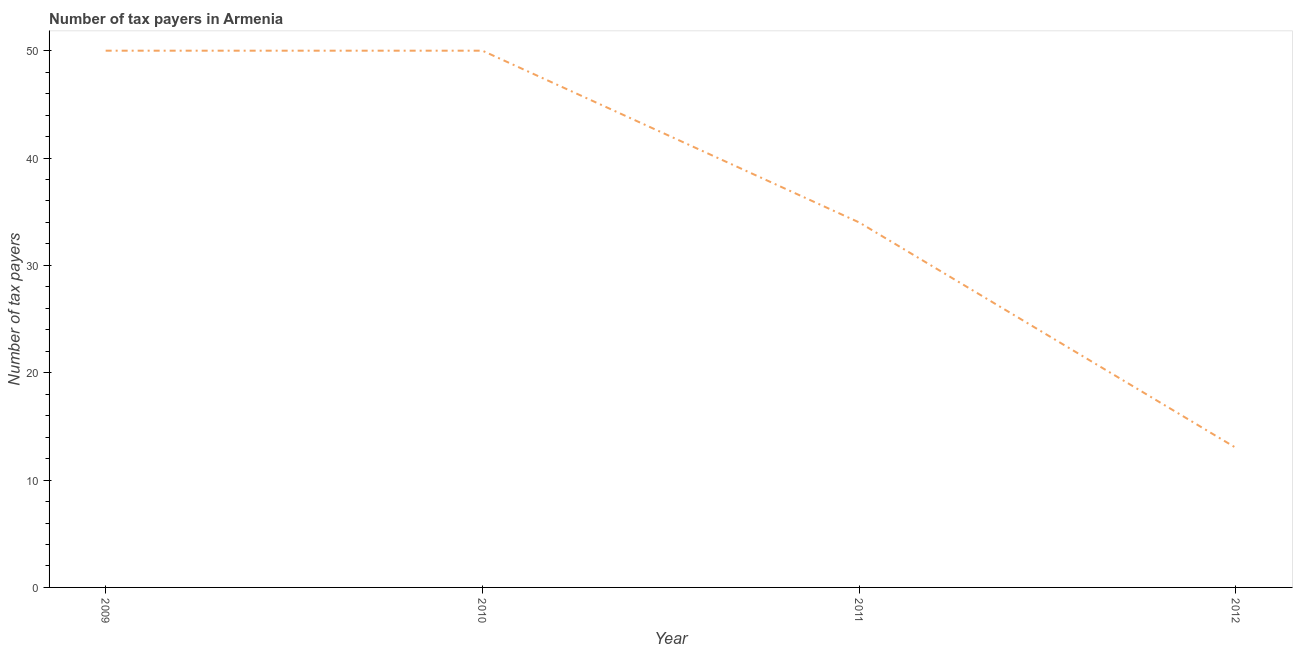What is the number of tax payers in 2009?
Provide a succinct answer. 50. Across all years, what is the maximum number of tax payers?
Offer a terse response. 50. Across all years, what is the minimum number of tax payers?
Your answer should be compact. 13. What is the sum of the number of tax payers?
Your response must be concise. 147. What is the difference between the number of tax payers in 2010 and 2011?
Your response must be concise. 16. What is the average number of tax payers per year?
Ensure brevity in your answer.  36.75. Do a majority of the years between 2009 and 2010 (inclusive) have number of tax payers greater than 22 ?
Your answer should be compact. Yes. What is the ratio of the number of tax payers in 2011 to that in 2012?
Your response must be concise. 2.62. What is the difference between the highest and the lowest number of tax payers?
Keep it short and to the point. 37. In how many years, is the number of tax payers greater than the average number of tax payers taken over all years?
Make the answer very short. 2. Does the number of tax payers monotonically increase over the years?
Your answer should be compact. No. How many lines are there?
Your answer should be compact. 1. How many years are there in the graph?
Give a very brief answer. 4. What is the difference between two consecutive major ticks on the Y-axis?
Your answer should be very brief. 10. What is the title of the graph?
Ensure brevity in your answer.  Number of tax payers in Armenia. What is the label or title of the X-axis?
Offer a very short reply. Year. What is the label or title of the Y-axis?
Offer a very short reply. Number of tax payers. What is the Number of tax payers in 2009?
Your answer should be compact. 50. What is the Number of tax payers in 2010?
Make the answer very short. 50. What is the Number of tax payers of 2012?
Keep it short and to the point. 13. What is the difference between the Number of tax payers in 2010 and 2011?
Provide a short and direct response. 16. What is the difference between the Number of tax payers in 2010 and 2012?
Ensure brevity in your answer.  37. What is the ratio of the Number of tax payers in 2009 to that in 2011?
Provide a short and direct response. 1.47. What is the ratio of the Number of tax payers in 2009 to that in 2012?
Make the answer very short. 3.85. What is the ratio of the Number of tax payers in 2010 to that in 2011?
Provide a short and direct response. 1.47. What is the ratio of the Number of tax payers in 2010 to that in 2012?
Your answer should be compact. 3.85. What is the ratio of the Number of tax payers in 2011 to that in 2012?
Your answer should be compact. 2.62. 